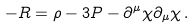Convert formula to latex. <formula><loc_0><loc_0><loc_500><loc_500>- R = \rho - 3 P - \partial ^ { \mu } \chi \partial _ { \mu } \chi \, .</formula> 